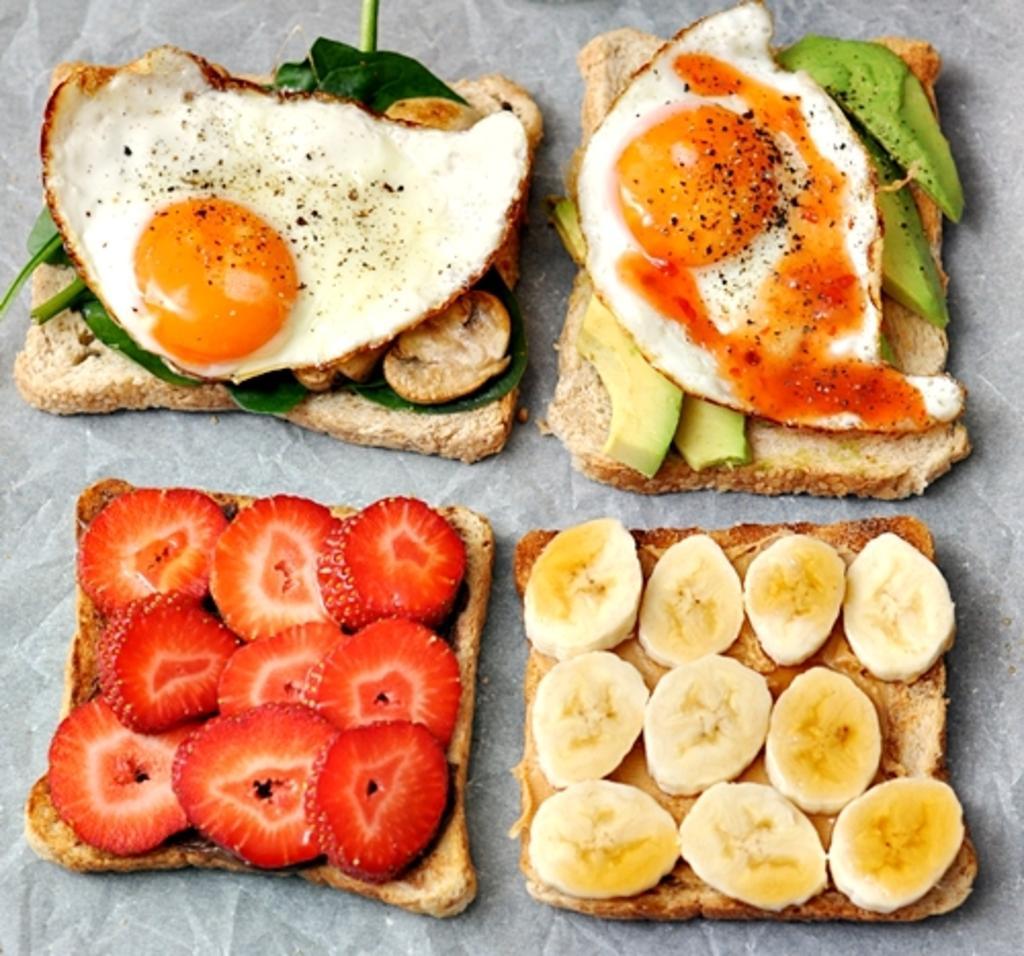Describe this image in one or two sentences. In this image I can see few food items, they are in brown, red, cream and green color and I can see white color background. 